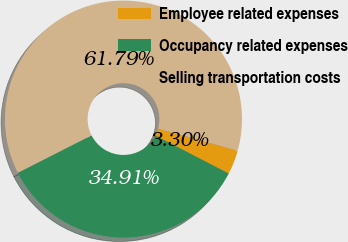<chart> <loc_0><loc_0><loc_500><loc_500><pie_chart><fcel>Employee related expenses<fcel>Occupancy related expenses<fcel>Selling transportation costs<nl><fcel>3.3%<fcel>34.91%<fcel>61.79%<nl></chart> 